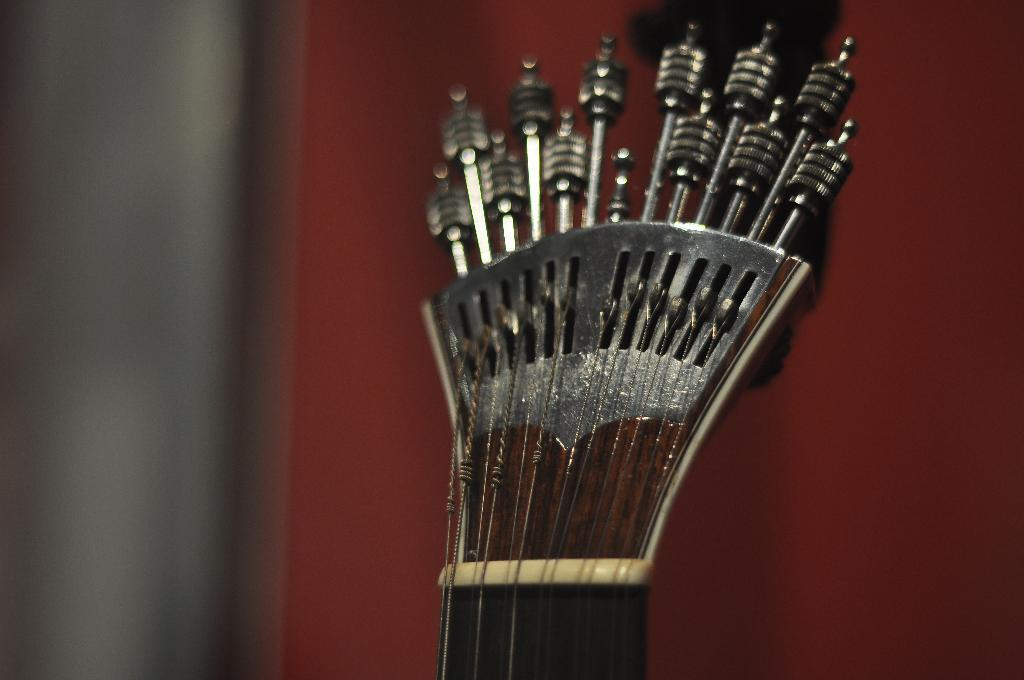What object in the image is associated with creating music? There is a musical instrument in the image. Can you describe the background of the image? The background of the image is blurry. What type of glue is being used to attach the design to the cork in the image? There is no glue, design, or cork present in the image. 